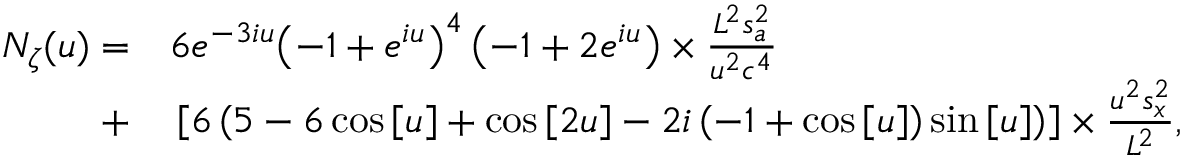<formula> <loc_0><loc_0><loc_500><loc_500>\begin{array} { r l } { { N _ { \zeta } } ( u ) = } & 6 { e ^ { - 3 i u } } { \left ( { - 1 + { e ^ { i u } } } \right ) ^ { 4 } } \left ( { - 1 + 2 { e ^ { i u } } } \right ) \times \frac { { { L ^ { 2 } } s _ { a } ^ { 2 } } } { { { u ^ { 2 } } { c ^ { 4 } } } } } \\ { + } & \left [ { 6 \left ( { 5 - 6 \cos \left [ u \right ] + \cos \left [ { 2 u } \right ] - 2 i \left ( { - 1 + \cos \left [ u \right ] } \right ) \sin \left [ u \right ] } \right ) } \right ] \times \frac { { { u ^ { 2 } } s _ { x } ^ { 2 } } } { { { L ^ { 2 } } } } , } \end{array}</formula> 